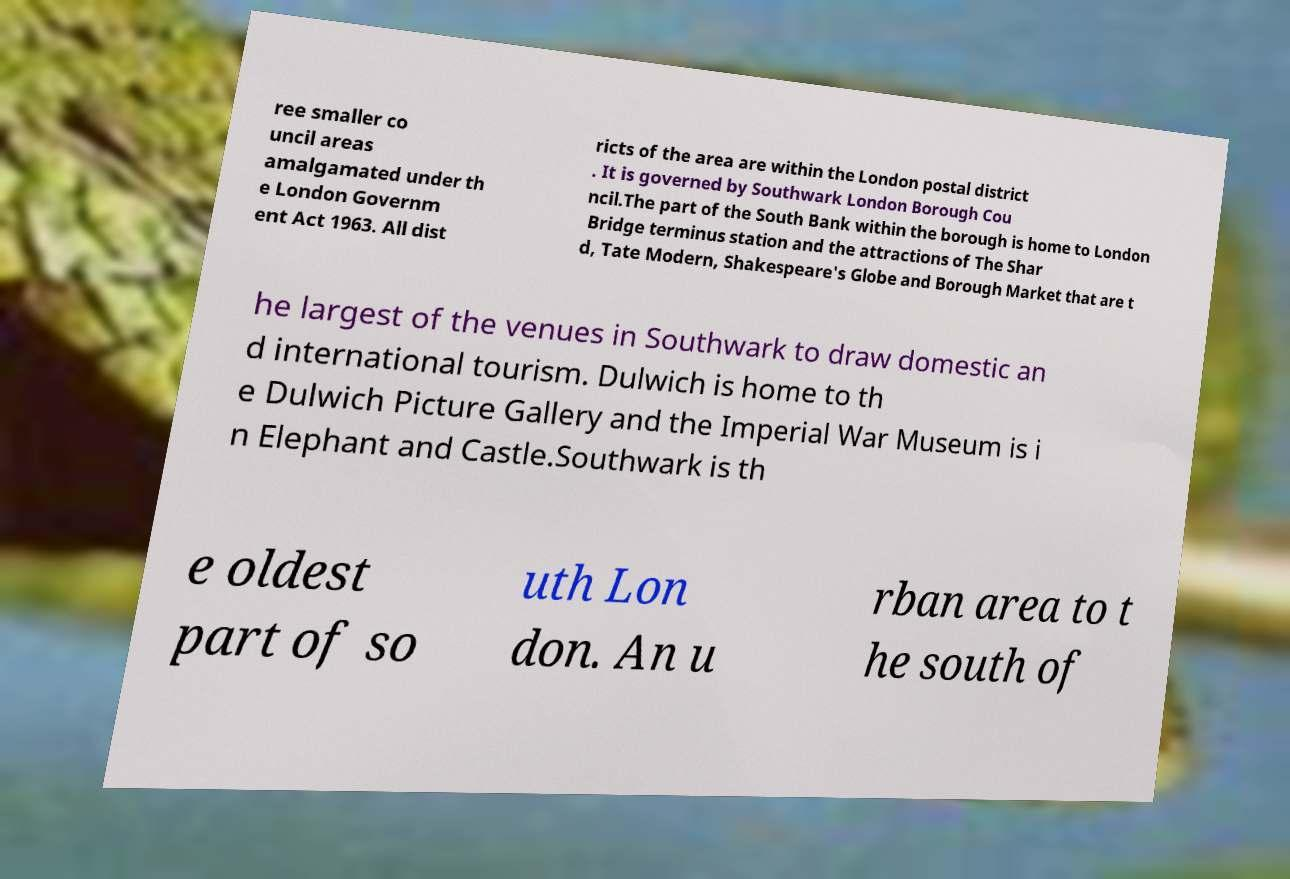Could you extract and type out the text from this image? ree smaller co uncil areas amalgamated under th e London Governm ent Act 1963. All dist ricts of the area are within the London postal district . It is governed by Southwark London Borough Cou ncil.The part of the South Bank within the borough is home to London Bridge terminus station and the attractions of The Shar d, Tate Modern, Shakespeare's Globe and Borough Market that are t he largest of the venues in Southwark to draw domestic an d international tourism. Dulwich is home to th e Dulwich Picture Gallery and the Imperial War Museum is i n Elephant and Castle.Southwark is th e oldest part of so uth Lon don. An u rban area to t he south of 